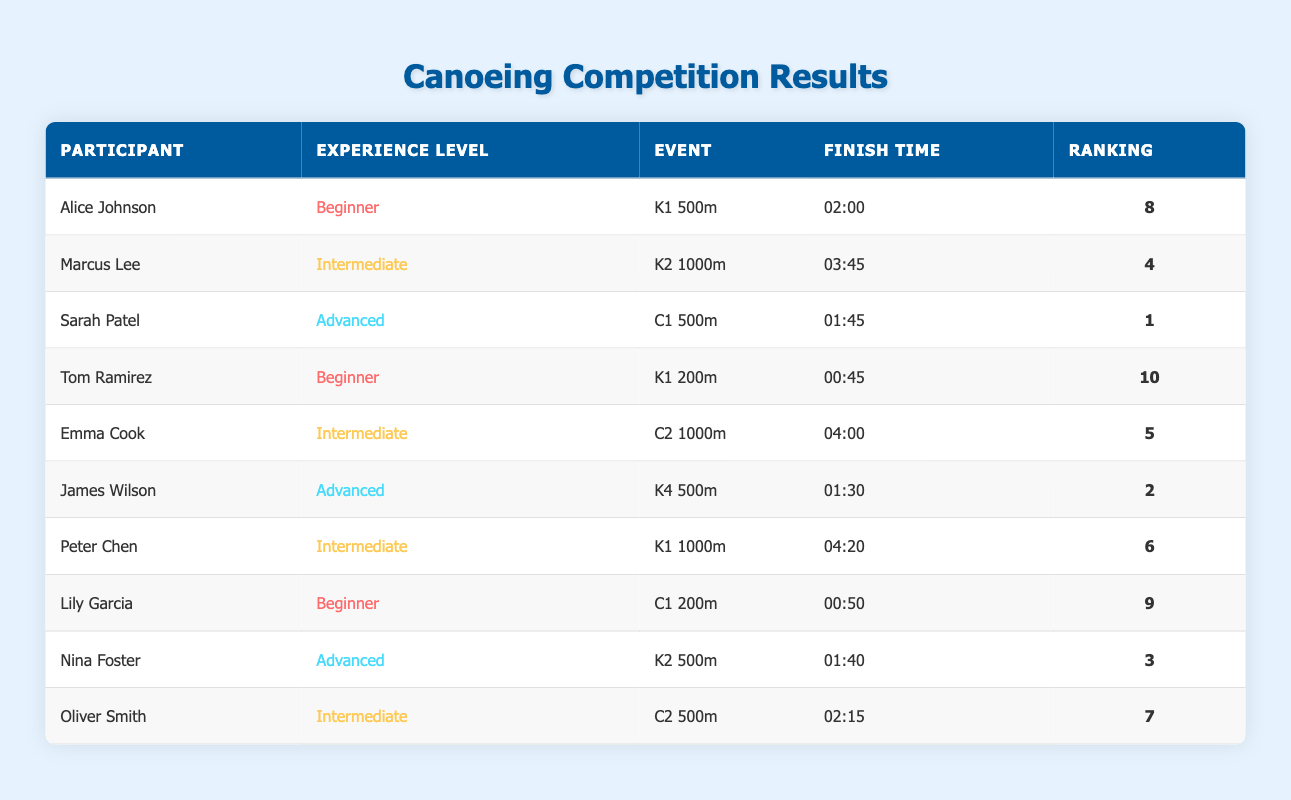What is the highest ranking achieved by a Beginner? From the table, Alice Johnson ranks 8th and Tom Ramirez ranks 10th, making 8 the highest ranking for a Beginner.
Answer: 8 Who finished with a better time, James Wilson or Nina Foster? James Wilson's finish time is 01:30, while Nina Foster's is 01:40. Since 01:30 is less than 01:40, James Wilson finished with a better time.
Answer: James Wilson What is the total number of participants in the Intermediate experience level? By counting the participants labeled as Intermediate (Marcus Lee, Emma Cook, Peter Chen, and Oliver Smith), there are 4 participants in this category.
Answer: 4 Is Sarah Patel's time the fastest among all participants? Sarah Patel finished in 01:45, which is faster than all other finish times detailed in the table, confirming that it is the fastest.
Answer: Yes What is the average finish time of the Advanced participants? The finish times for the Advanced participants are 01:45, 01:30, and 01:40. Converting these to seconds gives us (105 + 90 + 100) = 295 seconds. The average finish time is 295 seconds divided by 3, which equals approximately 98.33 seconds, or 01:38.33.
Answer: 01:38.33 Which Intermediate participant achieved the highest ranking and what was the ranking? Marcus Lee ranks 4th, Emma Cook ranks 5th, Peter Chen ranks 6th, and Oliver Smith ranks 7th. The highest among these is Marcus Lee with 4th place.
Answer: 4 How many events did the Advanced participants compete in and what are those events? Advanced participants competed in three events: C1 500m (Sarah Patel), K4 500m (James Wilson), and K2 500m (Nina Foster). Thus, a total of three events were contested.
Answer: 3 Find the difference in rankings between the lowest-ranked Beginner and the highest-ranked Advanced participant. The lowest-ranked Beginner is Tom Ramirez with a ranking of 10, and the highest-ranked Advanced participant is Sarah Patel with a ranking of 1. The difference is 10 - 1 = 9.
Answer: 9 Which Beginner had the fastest finish time and what was that time? Among the Beginners, Alice Johnson finished in 02:00 and Tom Ramirez in 00:45. Therefore, Tom Ramirez had the fastest finish time of 00:45.
Answer: 00:45 